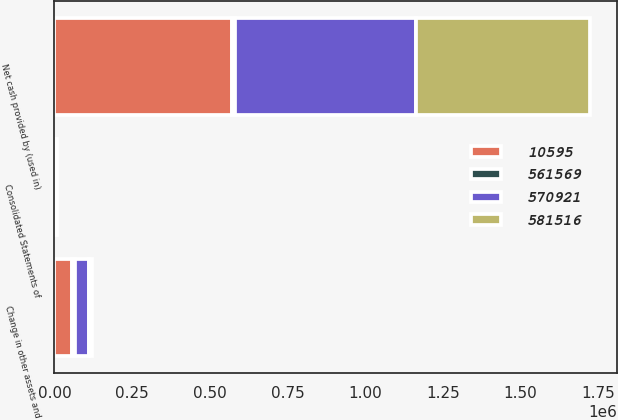Convert chart. <chart><loc_0><loc_0><loc_500><loc_500><stacked_bar_chart><ecel><fcel>Consolidated Statements of<fcel>Change in other assets and<fcel>Net cash provided by (used in)<nl><fcel>10595<fcel>2016<fcel>56204<fcel>570921<nl><fcel>561569<fcel>2016<fcel>10595<fcel>10595<nl><fcel>570921<fcel>2016<fcel>45609<fcel>581516<nl><fcel>581516<fcel>2015<fcel>8934<fcel>561569<nl></chart> 